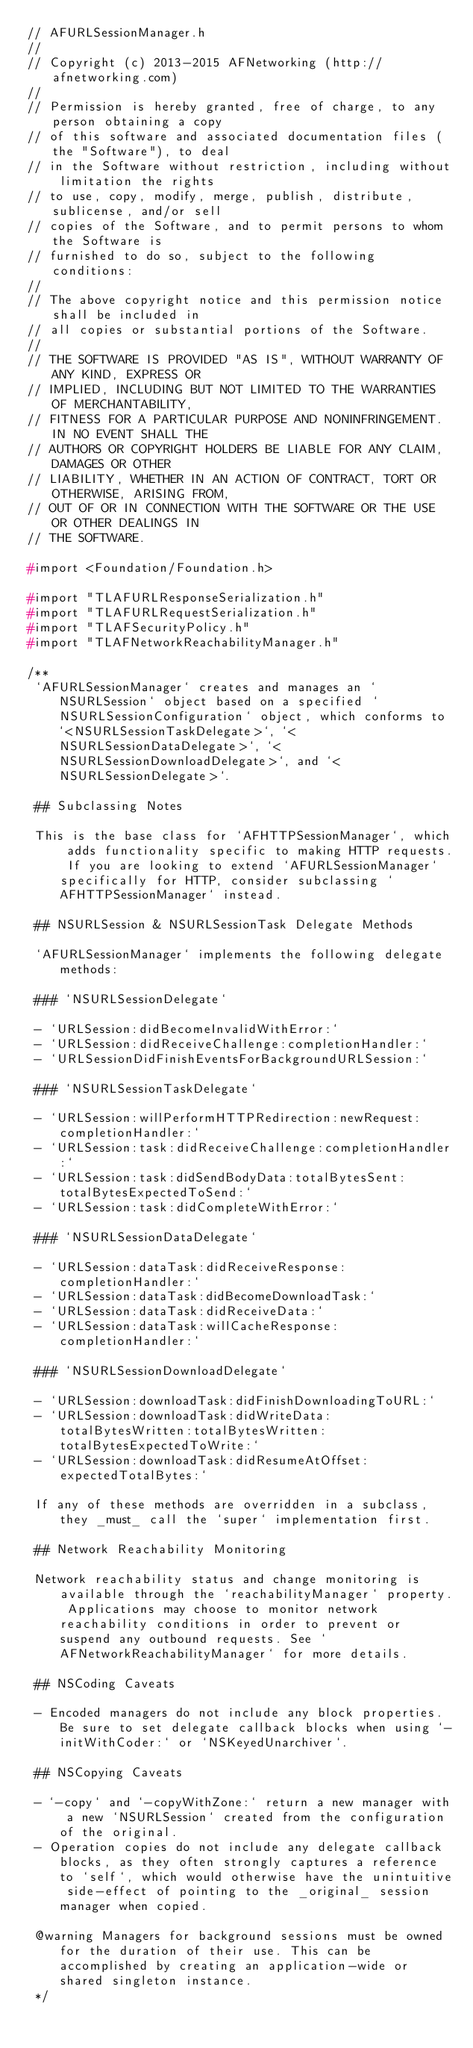<code> <loc_0><loc_0><loc_500><loc_500><_C_>// AFURLSessionManager.h
//
// Copyright (c) 2013-2015 AFNetworking (http://afnetworking.com)
//
// Permission is hereby granted, free of charge, to any person obtaining a copy
// of this software and associated documentation files (the "Software"), to deal
// in the Software without restriction, including without limitation the rights
// to use, copy, modify, merge, publish, distribute, sublicense, and/or sell
// copies of the Software, and to permit persons to whom the Software is
// furnished to do so, subject to the following conditions:
//
// The above copyright notice and this permission notice shall be included in
// all copies or substantial portions of the Software.
//
// THE SOFTWARE IS PROVIDED "AS IS", WITHOUT WARRANTY OF ANY KIND, EXPRESS OR
// IMPLIED, INCLUDING BUT NOT LIMITED TO THE WARRANTIES OF MERCHANTABILITY,
// FITNESS FOR A PARTICULAR PURPOSE AND NONINFRINGEMENT. IN NO EVENT SHALL THE
// AUTHORS OR COPYRIGHT HOLDERS BE LIABLE FOR ANY CLAIM, DAMAGES OR OTHER
// LIABILITY, WHETHER IN AN ACTION OF CONTRACT, TORT OR OTHERWISE, ARISING FROM,
// OUT OF OR IN CONNECTION WITH THE SOFTWARE OR THE USE OR OTHER DEALINGS IN
// THE SOFTWARE.

#import <Foundation/Foundation.h>

#import "TLAFURLResponseSerialization.h"
#import "TLAFURLRequestSerialization.h"
#import "TLAFSecurityPolicy.h"
#import "TLAFNetworkReachabilityManager.h"

/**
 `AFURLSessionManager` creates and manages an `NSURLSession` object based on a specified `NSURLSessionConfiguration` object, which conforms to `<NSURLSessionTaskDelegate>`, `<NSURLSessionDataDelegate>`, `<NSURLSessionDownloadDelegate>`, and `<NSURLSessionDelegate>`.

 ## Subclassing Notes

 This is the base class for `AFHTTPSessionManager`, which adds functionality specific to making HTTP requests. If you are looking to extend `AFURLSessionManager` specifically for HTTP, consider subclassing `AFHTTPSessionManager` instead.

 ## NSURLSession & NSURLSessionTask Delegate Methods

 `AFURLSessionManager` implements the following delegate methods:

 ### `NSURLSessionDelegate`

 - `URLSession:didBecomeInvalidWithError:`
 - `URLSession:didReceiveChallenge:completionHandler:`
 - `URLSessionDidFinishEventsForBackgroundURLSession:`

 ### `NSURLSessionTaskDelegate`

 - `URLSession:willPerformHTTPRedirection:newRequest:completionHandler:`
 - `URLSession:task:didReceiveChallenge:completionHandler:`
 - `URLSession:task:didSendBodyData:totalBytesSent:totalBytesExpectedToSend:`
 - `URLSession:task:didCompleteWithError:`

 ### `NSURLSessionDataDelegate`

 - `URLSession:dataTask:didReceiveResponse:completionHandler:`
 - `URLSession:dataTask:didBecomeDownloadTask:`
 - `URLSession:dataTask:didReceiveData:`
 - `URLSession:dataTask:willCacheResponse:completionHandler:`

 ### `NSURLSessionDownloadDelegate`

 - `URLSession:downloadTask:didFinishDownloadingToURL:`
 - `URLSession:downloadTask:didWriteData:totalBytesWritten:totalBytesWritten:totalBytesExpectedToWrite:`
 - `URLSession:downloadTask:didResumeAtOffset:expectedTotalBytes:`

 If any of these methods are overridden in a subclass, they _must_ call the `super` implementation first.

 ## Network Reachability Monitoring

 Network reachability status and change monitoring is available through the `reachabilityManager` property. Applications may choose to monitor network reachability conditions in order to prevent or suspend any outbound requests. See `AFNetworkReachabilityManager` for more details.

 ## NSCoding Caveats

 - Encoded managers do not include any block properties. Be sure to set delegate callback blocks when using `-initWithCoder:` or `NSKeyedUnarchiver`.

 ## NSCopying Caveats

 - `-copy` and `-copyWithZone:` return a new manager with a new `NSURLSession` created from the configuration of the original.
 - Operation copies do not include any delegate callback blocks, as they often strongly captures a reference to `self`, which would otherwise have the unintuitive side-effect of pointing to the _original_ session manager when copied.

 @warning Managers for background sessions must be owned for the duration of their use. This can be accomplished by creating an application-wide or shared singleton instance.
 */
</code> 